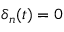Convert formula to latex. <formula><loc_0><loc_0><loc_500><loc_500>\delta _ { n } ( t ) = 0</formula> 